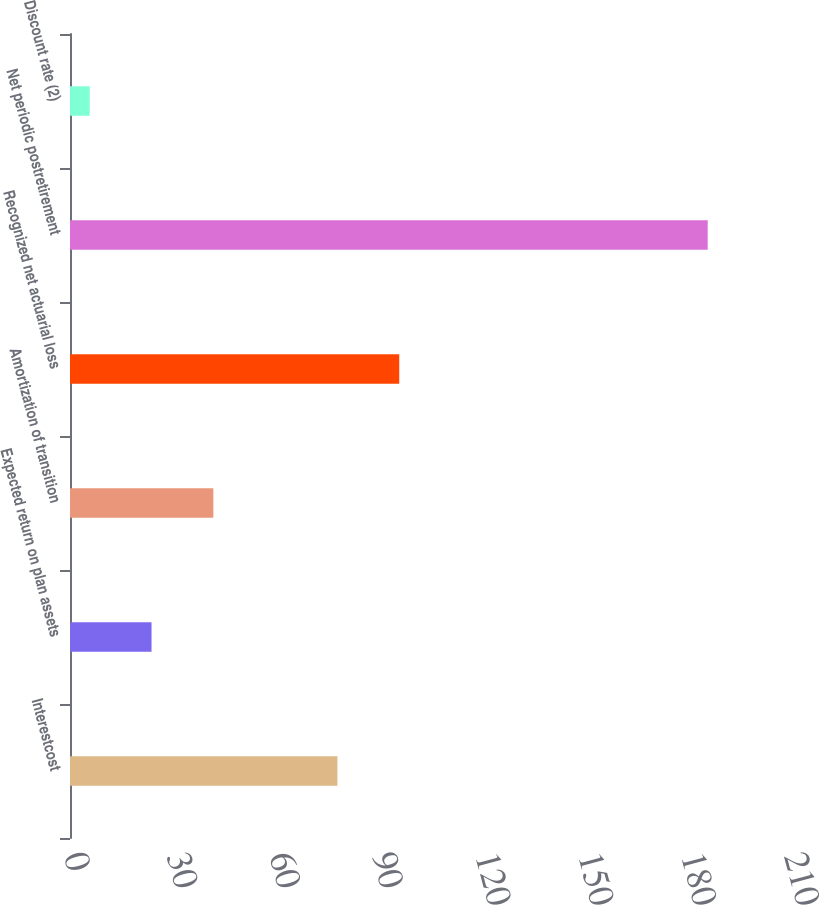Convert chart. <chart><loc_0><loc_0><loc_500><loc_500><bar_chart><fcel>Interestcost<fcel>Expected return on plan assets<fcel>Amortization of transition<fcel>Recognized net actuarial loss<fcel>Net periodic postretirement<fcel>Discount rate (2)<nl><fcel>78<fcel>23.78<fcel>41.81<fcel>96.03<fcel>186<fcel>5.75<nl></chart> 